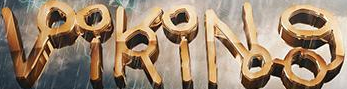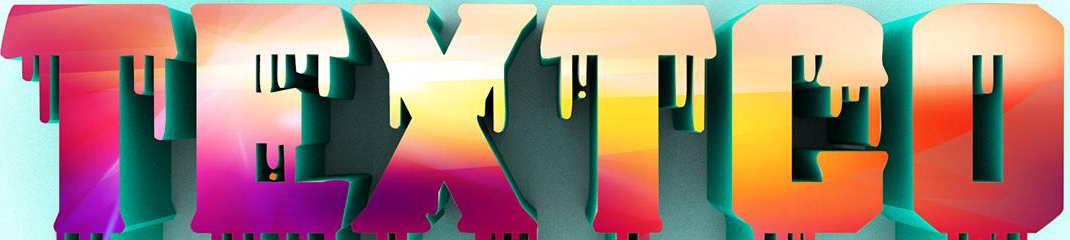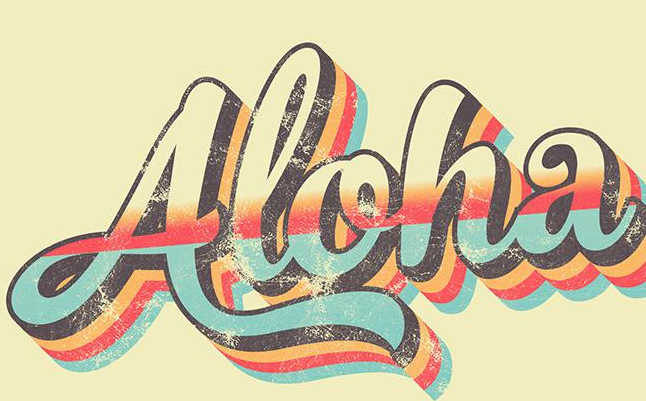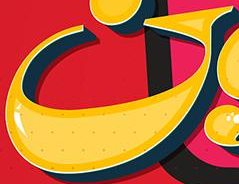What words can you see in these images in sequence, separated by a semicolon? VikiNg; TEXTCO; Aloha; G 